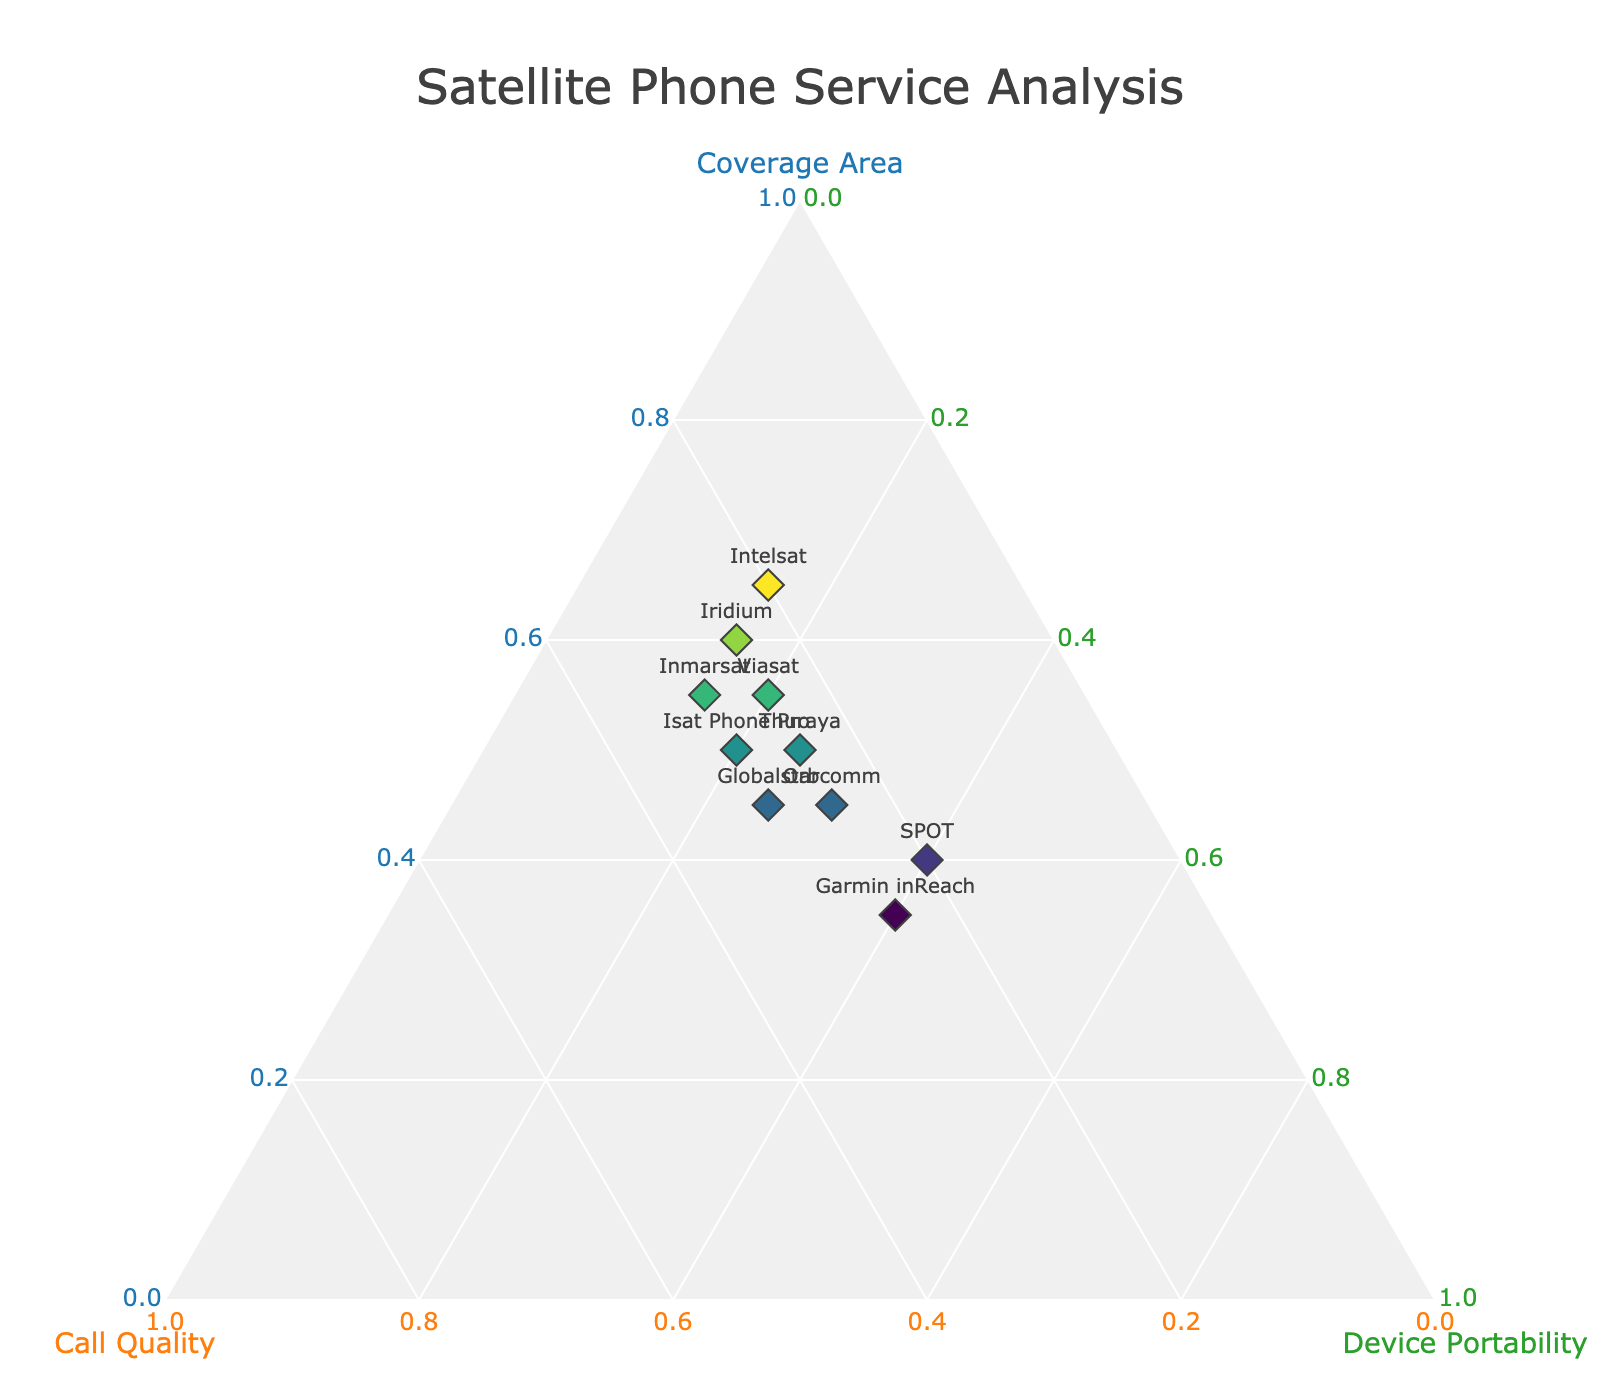What is the title of the figure? The title of the figure is found at the top of the plot and is displayed prominently. Referring to the data, we can identify the title specified in the code's layout section.
Answer: Satellite Phone Service Analysis What does the plot's a-axis represent? The plot's a-axis is labeled with the attribute it represents. This can be found by referring to the details of the ternary axis titles. In this case, the a-axis is labeled as 'Coverage Area'.
Answer: Coverage Area How many service providers are shown in the plot? Each service provider is represented as a data point in the ternary plot. Counting the unique labels provided in the data gives us the total number of service providers displayed.
Answer: 10 Which service provider has the highest score for device portability? By observing the c-axis of the ternary plot, which represents device portability, we can identify the data point that aligns closest to the device portability axis. The highest score for device portability in the provided data is 0.40, corresponding to SPOT and Garmin inReach.
Answer: SPOT and Garmin inReach Which service provider offers the best call quality? Referring to the b-axis of the plot, which represents call quality, we can look for the provider with the highest value on this axis. In the data, the highest call quality score is 0.30, shared by Globalstar, Inmarsat, and Isat Phone Pro.
Answer: Globalstar, Inmarsat, and Isat Phone Pro What is the combined score for coverage area and call quality for Intelsat? From the provided data, sum the values for coverage area and call quality for Intelsat (0.65 and 0.20 respectively). The combined score is the result of adding these two values together.
Answer: 0.85 Which service provider has a better call quality: Orbcomm or Viasat? We compare the call quality values from the data for both providers. Orbcomm has a call quality of 0.25, while Viasat has a call quality of 0.25. Since their values are equal, neither provider has a better call quality.
Answer: They have equal call quality How does Iridium's device portability compare to Thuraya's? From the data, compare Iridium's device portability score (0.15) to Thuraya's score (0.25), establishing that Iridium's device portability is lower than Thuraya's.
Answer: Lower Which provider offers the best balance between coverage area and device portability? The best balance is achieved by a provider whose scores for coverage area and device portability are closest in value. In the data, Globalstar (0.45 coverage, 0.25 portability), and Thuraya (0.50 coverage, 0.25 portability) show close values, making Thuraya the provider with a more balanced approach closer to an equal split.
Answer: Thuraya Which providers have a device portability score of 0.15? Referring to the data, identify which service providers have a device portability score of 0.15. The listed providers with this score are Iridium, Inmarsat, and Intelsat.
Answer: Iridium, Inmarsat, and Intelsat 